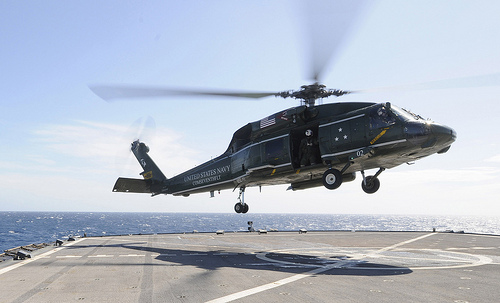<image>
Can you confirm if the helicopter is above the ground? Yes. The helicopter is positioned above the ground in the vertical space, higher up in the scene. 